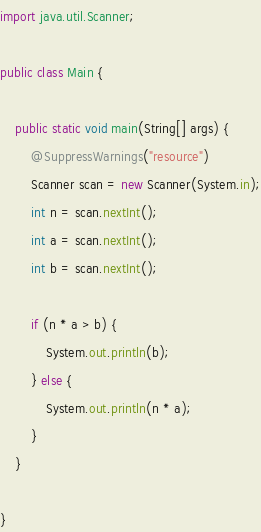<code> <loc_0><loc_0><loc_500><loc_500><_Java_>import java.util.Scanner;

public class Main {

	public static void main(String[] args) {
		@SuppressWarnings("resource")
		Scanner scan = new Scanner(System.in);
		int n = scan.nextInt();
		int a = scan.nextInt();
		int b = scan.nextInt();

		if (n * a > b) {
			System.out.println(b);
		} else {
			System.out.println(n * a);
		}
	}

}
</code> 